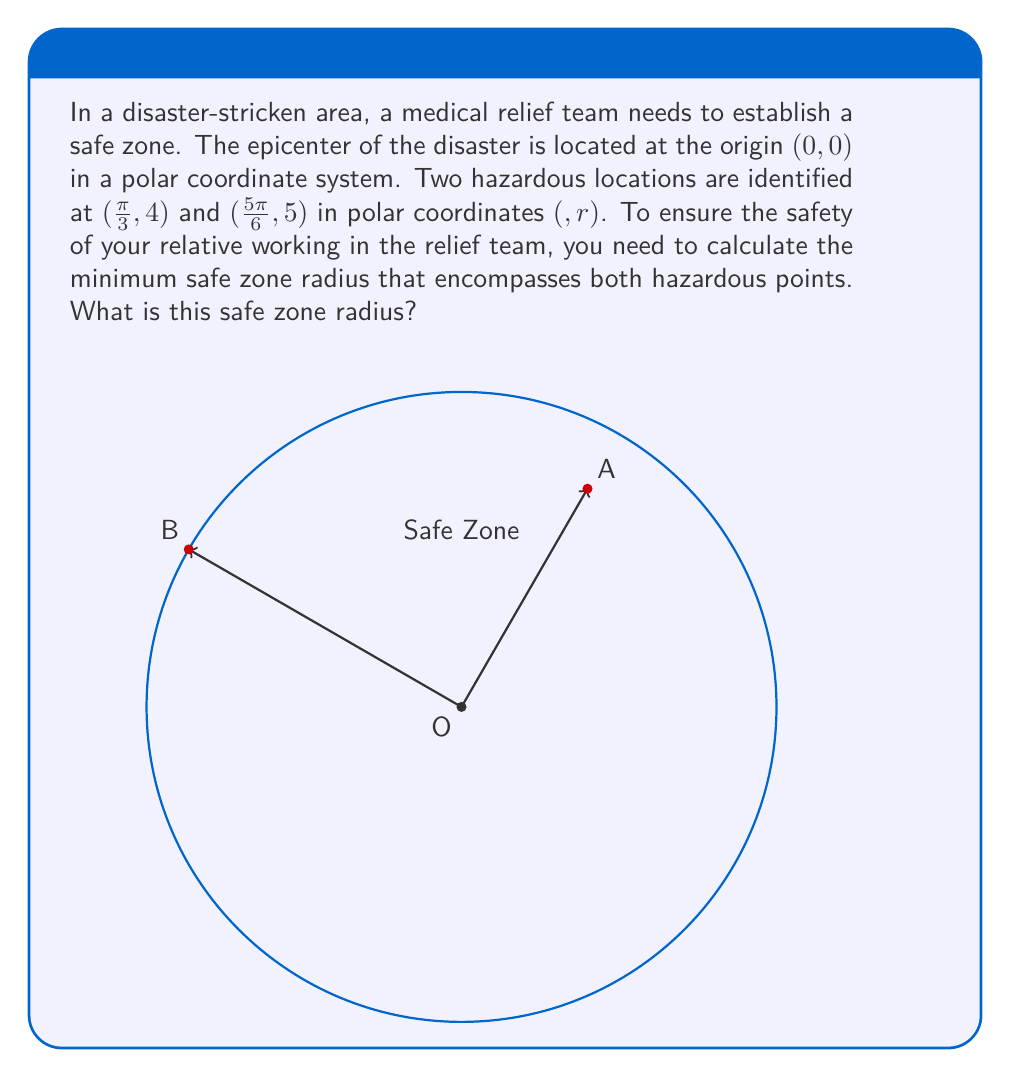Solve this math problem. To find the minimum safe zone radius, we need to determine which of the two hazardous points is farther from the origin. The point with the larger radial coordinate will define the safe zone radius.

Let's examine the two points:
1. Point A: $(\frac{\pi}{3}, 4)$
2. Point B: $(\frac{5\pi}{6}, 5)$

In polar coordinates $(θ, r)$, the second component $r$ represents the distance from the origin. 

For Point A: $r_A = 4$
For Point B: $r_B = 5$

Since $r_B > r_A$, Point B is farther from the origin.

Therefore, the minimum safe zone radius should be equal to the radial coordinate of Point B, which is 5 units.

This radius ensures that both hazardous points are contained within the safe zone, providing maximum safety for the relief team, including your relative.
Answer: The minimum safe zone radius is 5 units. 